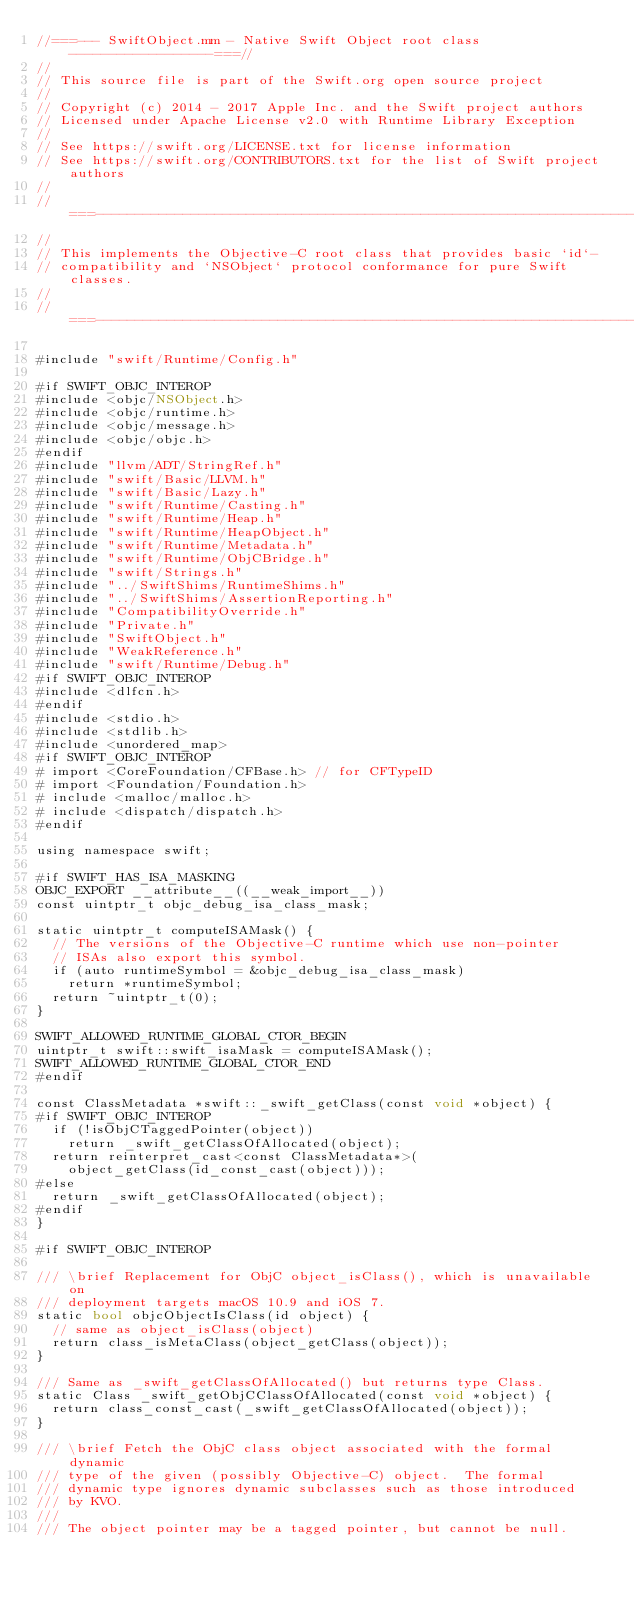<code> <loc_0><loc_0><loc_500><loc_500><_ObjectiveC_>//===--- SwiftObject.mm - Native Swift Object root class ------------------===//
//
// This source file is part of the Swift.org open source project
//
// Copyright (c) 2014 - 2017 Apple Inc. and the Swift project authors
// Licensed under Apache License v2.0 with Runtime Library Exception
//
// See https://swift.org/LICENSE.txt for license information
// See https://swift.org/CONTRIBUTORS.txt for the list of Swift project authors
//
//===----------------------------------------------------------------------===//
//
// This implements the Objective-C root class that provides basic `id`-
// compatibility and `NSObject` protocol conformance for pure Swift classes.
//
//===----------------------------------------------------------------------===//

#include "swift/Runtime/Config.h"

#if SWIFT_OBJC_INTEROP
#include <objc/NSObject.h>
#include <objc/runtime.h>
#include <objc/message.h>
#include <objc/objc.h>
#endif
#include "llvm/ADT/StringRef.h"
#include "swift/Basic/LLVM.h"
#include "swift/Basic/Lazy.h"
#include "swift/Runtime/Casting.h"
#include "swift/Runtime/Heap.h"
#include "swift/Runtime/HeapObject.h"
#include "swift/Runtime/Metadata.h"
#include "swift/Runtime/ObjCBridge.h"
#include "swift/Strings.h"
#include "../SwiftShims/RuntimeShims.h"
#include "../SwiftShims/AssertionReporting.h"
#include "CompatibilityOverride.h"
#include "Private.h"
#include "SwiftObject.h"
#include "WeakReference.h"
#include "swift/Runtime/Debug.h"
#if SWIFT_OBJC_INTEROP
#include <dlfcn.h>
#endif
#include <stdio.h>
#include <stdlib.h>
#include <unordered_map>
#if SWIFT_OBJC_INTEROP
# import <CoreFoundation/CFBase.h> // for CFTypeID
# import <Foundation/Foundation.h>
# include <malloc/malloc.h>
# include <dispatch/dispatch.h>
#endif

using namespace swift;

#if SWIFT_HAS_ISA_MASKING
OBJC_EXPORT __attribute__((__weak_import__))
const uintptr_t objc_debug_isa_class_mask;

static uintptr_t computeISAMask() {
  // The versions of the Objective-C runtime which use non-pointer
  // ISAs also export this symbol.
  if (auto runtimeSymbol = &objc_debug_isa_class_mask)
    return *runtimeSymbol;
  return ~uintptr_t(0);
}

SWIFT_ALLOWED_RUNTIME_GLOBAL_CTOR_BEGIN
uintptr_t swift::swift_isaMask = computeISAMask();
SWIFT_ALLOWED_RUNTIME_GLOBAL_CTOR_END
#endif

const ClassMetadata *swift::_swift_getClass(const void *object) {
#if SWIFT_OBJC_INTEROP
  if (!isObjCTaggedPointer(object))
    return _swift_getClassOfAllocated(object);
  return reinterpret_cast<const ClassMetadata*>(
    object_getClass(id_const_cast(object)));
#else
  return _swift_getClassOfAllocated(object);
#endif
}

#if SWIFT_OBJC_INTEROP

/// \brief Replacement for ObjC object_isClass(), which is unavailable on
/// deployment targets macOS 10.9 and iOS 7.
static bool objcObjectIsClass(id object) {
  // same as object_isClass(object)
  return class_isMetaClass(object_getClass(object));
}

/// Same as _swift_getClassOfAllocated() but returns type Class.
static Class _swift_getObjCClassOfAllocated(const void *object) {
  return class_const_cast(_swift_getClassOfAllocated(object));
}

/// \brief Fetch the ObjC class object associated with the formal dynamic
/// type of the given (possibly Objective-C) object.  The formal
/// dynamic type ignores dynamic subclasses such as those introduced
/// by KVO.
///
/// The object pointer may be a tagged pointer, but cannot be null.</code> 